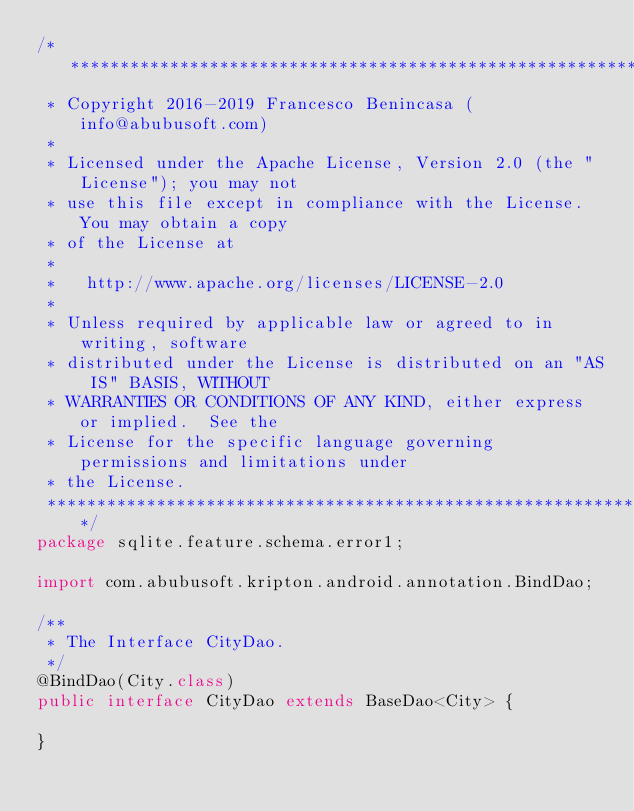Convert code to text. <code><loc_0><loc_0><loc_500><loc_500><_Java_>/*******************************************************************************
 * Copyright 2016-2019 Francesco Benincasa (info@abubusoft.com)
 * 
 * Licensed under the Apache License, Version 2.0 (the "License"); you may not
 * use this file except in compliance with the License.  You may obtain a copy
 * of the License at
 * 
 *   http://www.apache.org/licenses/LICENSE-2.0
 * 
 * Unless required by applicable law or agreed to in writing, software
 * distributed under the License is distributed on an "AS IS" BASIS, WITHOUT
 * WARRANTIES OR CONDITIONS OF ANY KIND, either express or implied.  See the
 * License for the specific language governing permissions and limitations under
 * the License.
 ******************************************************************************/
package sqlite.feature.schema.error1;

import com.abubusoft.kripton.android.annotation.BindDao;

/**
 * The Interface CityDao.
 */
@BindDao(City.class)
public interface CityDao extends BaseDao<City> {

}
</code> 